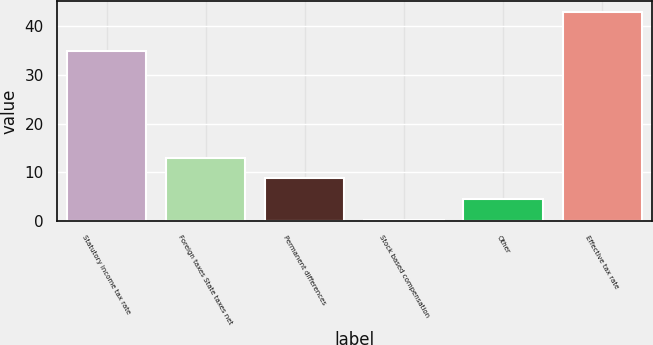<chart> <loc_0><loc_0><loc_500><loc_500><bar_chart><fcel>Statutory income tax rate<fcel>Foreign taxes State taxes net<fcel>Permanent differences<fcel>Stock based compensation<fcel>Other<fcel>Effective tax rate<nl><fcel>35<fcel>13.04<fcel>8.76<fcel>0.2<fcel>4.48<fcel>43<nl></chart> 